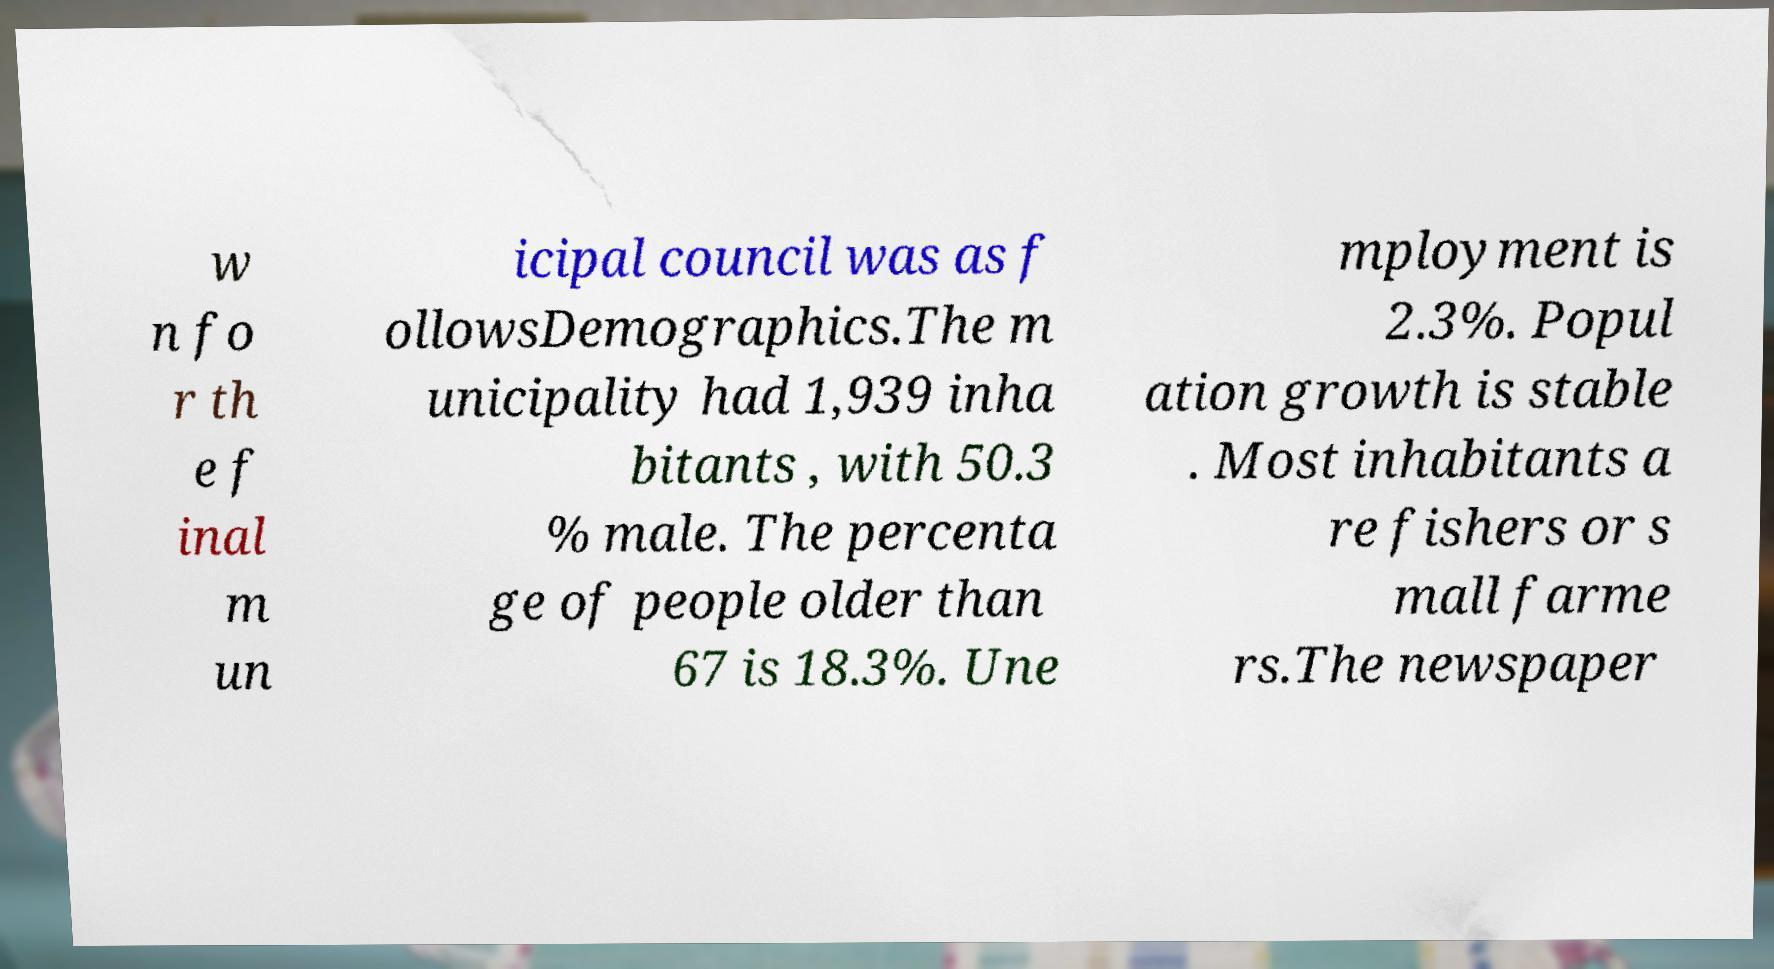Could you assist in decoding the text presented in this image and type it out clearly? w n fo r th e f inal m un icipal council was as f ollowsDemographics.The m unicipality had 1,939 inha bitants , with 50.3 % male. The percenta ge of people older than 67 is 18.3%. Une mployment is 2.3%. Popul ation growth is stable . Most inhabitants a re fishers or s mall farme rs.The newspaper 